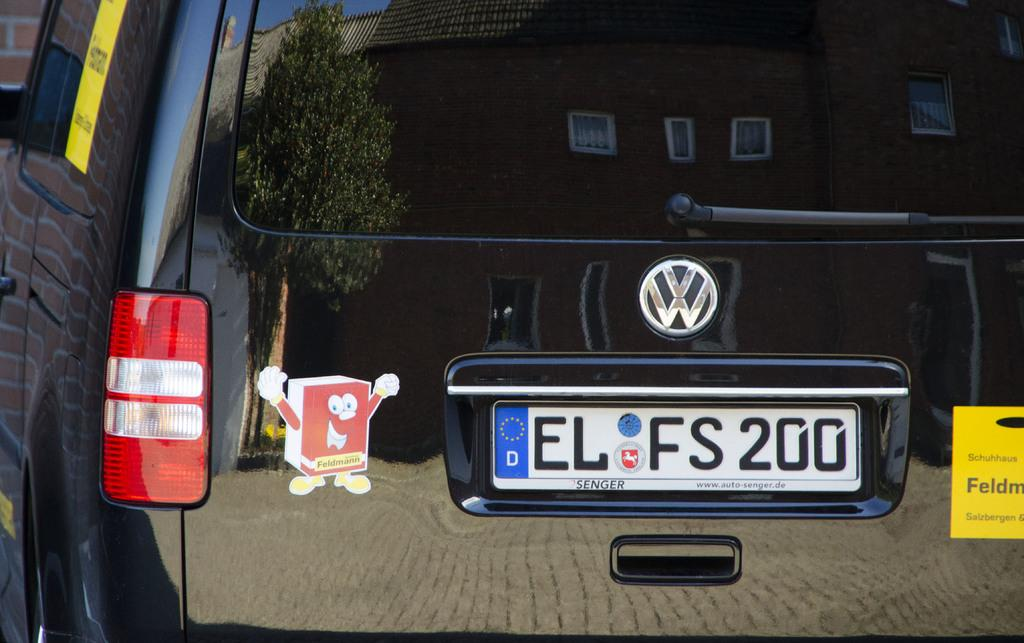<image>
Give a short and clear explanation of the subsequent image. black vw car with the license place elfs200 